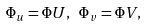<formula> <loc_0><loc_0><loc_500><loc_500>\Phi _ { u } = \Phi U , \ \Phi _ { v } = \Phi V ,</formula> 